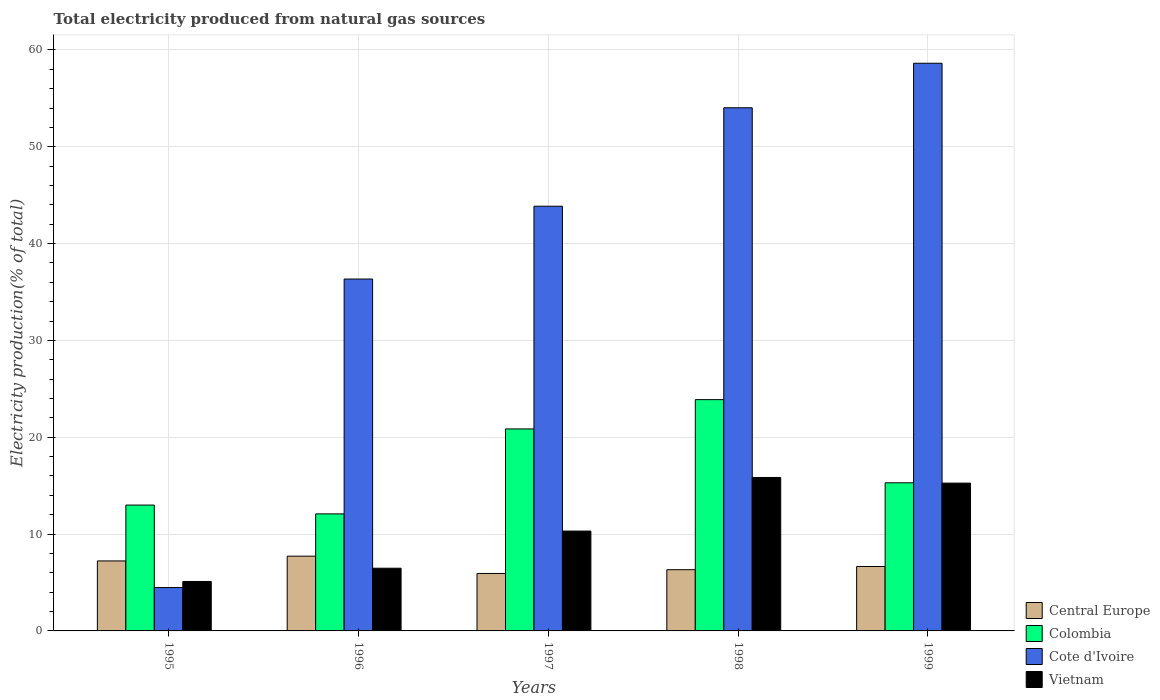How many groups of bars are there?
Offer a terse response. 5. How many bars are there on the 5th tick from the left?
Keep it short and to the point. 4. In how many cases, is the number of bars for a given year not equal to the number of legend labels?
Provide a succinct answer. 0. What is the total electricity produced in Colombia in 1998?
Keep it short and to the point. 23.89. Across all years, what is the maximum total electricity produced in Vietnam?
Offer a terse response. 15.85. Across all years, what is the minimum total electricity produced in Central Europe?
Offer a terse response. 5.93. In which year was the total electricity produced in Colombia maximum?
Keep it short and to the point. 1998. In which year was the total electricity produced in Vietnam minimum?
Provide a short and direct response. 1995. What is the total total electricity produced in Colombia in the graph?
Offer a terse response. 85.13. What is the difference between the total electricity produced in Cote d'Ivoire in 1996 and that in 1998?
Your answer should be compact. -17.69. What is the difference between the total electricity produced in Colombia in 1998 and the total electricity produced in Vietnam in 1995?
Your response must be concise. 18.78. What is the average total electricity produced in Vietnam per year?
Give a very brief answer. 10.6. In the year 1999, what is the difference between the total electricity produced in Colombia and total electricity produced in Cote d'Ivoire?
Offer a terse response. -43.33. What is the ratio of the total electricity produced in Central Europe in 1995 to that in 1999?
Provide a succinct answer. 1.09. Is the total electricity produced in Vietnam in 1996 less than that in 1999?
Keep it short and to the point. Yes. What is the difference between the highest and the second highest total electricity produced in Cote d'Ivoire?
Your answer should be very brief. 4.6. What is the difference between the highest and the lowest total electricity produced in Cote d'Ivoire?
Your answer should be very brief. 54.15. In how many years, is the total electricity produced in Colombia greater than the average total electricity produced in Colombia taken over all years?
Your response must be concise. 2. Is the sum of the total electricity produced in Vietnam in 1995 and 1998 greater than the maximum total electricity produced in Cote d'Ivoire across all years?
Keep it short and to the point. No. What does the 4th bar from the right in 1995 represents?
Provide a short and direct response. Central Europe. Is it the case that in every year, the sum of the total electricity produced in Cote d'Ivoire and total electricity produced in Colombia is greater than the total electricity produced in Vietnam?
Offer a very short reply. Yes. How many bars are there?
Offer a terse response. 20. What is the difference between two consecutive major ticks on the Y-axis?
Make the answer very short. 10. Are the values on the major ticks of Y-axis written in scientific E-notation?
Your answer should be very brief. No. Does the graph contain any zero values?
Make the answer very short. No. Does the graph contain grids?
Your response must be concise. Yes. Where does the legend appear in the graph?
Offer a terse response. Bottom right. How are the legend labels stacked?
Keep it short and to the point. Vertical. What is the title of the graph?
Ensure brevity in your answer.  Total electricity produced from natural gas sources. What is the label or title of the X-axis?
Make the answer very short. Years. What is the label or title of the Y-axis?
Make the answer very short. Electricity production(% of total). What is the Electricity production(% of total) in Central Europe in 1995?
Your answer should be compact. 7.23. What is the Electricity production(% of total) of Colombia in 1995?
Keep it short and to the point. 13. What is the Electricity production(% of total) of Cote d'Ivoire in 1995?
Offer a terse response. 4.48. What is the Electricity production(% of total) in Vietnam in 1995?
Offer a terse response. 5.11. What is the Electricity production(% of total) in Central Europe in 1996?
Provide a succinct answer. 7.72. What is the Electricity production(% of total) of Colombia in 1996?
Ensure brevity in your answer.  12.09. What is the Electricity production(% of total) in Cote d'Ivoire in 1996?
Provide a short and direct response. 36.34. What is the Electricity production(% of total) in Vietnam in 1996?
Offer a terse response. 6.47. What is the Electricity production(% of total) in Central Europe in 1997?
Offer a terse response. 5.93. What is the Electricity production(% of total) in Colombia in 1997?
Offer a terse response. 20.86. What is the Electricity production(% of total) of Cote d'Ivoire in 1997?
Give a very brief answer. 43.86. What is the Electricity production(% of total) of Vietnam in 1997?
Your response must be concise. 10.31. What is the Electricity production(% of total) in Central Europe in 1998?
Offer a terse response. 6.32. What is the Electricity production(% of total) of Colombia in 1998?
Provide a succinct answer. 23.89. What is the Electricity production(% of total) in Cote d'Ivoire in 1998?
Offer a very short reply. 54.03. What is the Electricity production(% of total) in Vietnam in 1998?
Provide a short and direct response. 15.85. What is the Electricity production(% of total) in Central Europe in 1999?
Your answer should be very brief. 6.65. What is the Electricity production(% of total) in Colombia in 1999?
Provide a short and direct response. 15.3. What is the Electricity production(% of total) in Cote d'Ivoire in 1999?
Your answer should be compact. 58.63. What is the Electricity production(% of total) in Vietnam in 1999?
Make the answer very short. 15.26. Across all years, what is the maximum Electricity production(% of total) in Central Europe?
Your answer should be compact. 7.72. Across all years, what is the maximum Electricity production(% of total) of Colombia?
Your answer should be very brief. 23.89. Across all years, what is the maximum Electricity production(% of total) in Cote d'Ivoire?
Your answer should be very brief. 58.63. Across all years, what is the maximum Electricity production(% of total) of Vietnam?
Offer a very short reply. 15.85. Across all years, what is the minimum Electricity production(% of total) of Central Europe?
Provide a short and direct response. 5.93. Across all years, what is the minimum Electricity production(% of total) in Colombia?
Provide a short and direct response. 12.09. Across all years, what is the minimum Electricity production(% of total) in Cote d'Ivoire?
Give a very brief answer. 4.48. Across all years, what is the minimum Electricity production(% of total) of Vietnam?
Offer a very short reply. 5.11. What is the total Electricity production(% of total) in Central Europe in the graph?
Provide a short and direct response. 33.86. What is the total Electricity production(% of total) of Colombia in the graph?
Provide a succinct answer. 85.13. What is the total Electricity production(% of total) of Cote d'Ivoire in the graph?
Offer a terse response. 197.33. What is the total Electricity production(% of total) in Vietnam in the graph?
Give a very brief answer. 53. What is the difference between the Electricity production(% of total) in Central Europe in 1995 and that in 1996?
Give a very brief answer. -0.49. What is the difference between the Electricity production(% of total) in Colombia in 1995 and that in 1996?
Your answer should be very brief. 0.91. What is the difference between the Electricity production(% of total) in Cote d'Ivoire in 1995 and that in 1996?
Keep it short and to the point. -31.86. What is the difference between the Electricity production(% of total) in Vietnam in 1995 and that in 1996?
Offer a very short reply. -1.37. What is the difference between the Electricity production(% of total) of Central Europe in 1995 and that in 1997?
Your answer should be very brief. 1.29. What is the difference between the Electricity production(% of total) in Colombia in 1995 and that in 1997?
Provide a short and direct response. -7.86. What is the difference between the Electricity production(% of total) in Cote d'Ivoire in 1995 and that in 1997?
Provide a short and direct response. -39.38. What is the difference between the Electricity production(% of total) in Vietnam in 1995 and that in 1997?
Make the answer very short. -5.21. What is the difference between the Electricity production(% of total) of Central Europe in 1995 and that in 1998?
Your answer should be very brief. 0.91. What is the difference between the Electricity production(% of total) in Colombia in 1995 and that in 1998?
Keep it short and to the point. -10.89. What is the difference between the Electricity production(% of total) in Cote d'Ivoire in 1995 and that in 1998?
Offer a terse response. -49.55. What is the difference between the Electricity production(% of total) of Vietnam in 1995 and that in 1998?
Keep it short and to the point. -10.74. What is the difference between the Electricity production(% of total) in Central Europe in 1995 and that in 1999?
Ensure brevity in your answer.  0.58. What is the difference between the Electricity production(% of total) of Colombia in 1995 and that in 1999?
Make the answer very short. -2.3. What is the difference between the Electricity production(% of total) of Cote d'Ivoire in 1995 and that in 1999?
Your answer should be very brief. -54.15. What is the difference between the Electricity production(% of total) of Vietnam in 1995 and that in 1999?
Your response must be concise. -10.16. What is the difference between the Electricity production(% of total) of Central Europe in 1996 and that in 1997?
Keep it short and to the point. 1.79. What is the difference between the Electricity production(% of total) in Colombia in 1996 and that in 1997?
Ensure brevity in your answer.  -8.77. What is the difference between the Electricity production(% of total) in Cote d'Ivoire in 1996 and that in 1997?
Provide a short and direct response. -7.52. What is the difference between the Electricity production(% of total) of Vietnam in 1996 and that in 1997?
Your answer should be very brief. -3.84. What is the difference between the Electricity production(% of total) in Central Europe in 1996 and that in 1998?
Provide a succinct answer. 1.4. What is the difference between the Electricity production(% of total) in Colombia in 1996 and that in 1998?
Your answer should be very brief. -11.8. What is the difference between the Electricity production(% of total) of Cote d'Ivoire in 1996 and that in 1998?
Offer a very short reply. -17.69. What is the difference between the Electricity production(% of total) of Vietnam in 1996 and that in 1998?
Provide a short and direct response. -9.37. What is the difference between the Electricity production(% of total) in Central Europe in 1996 and that in 1999?
Offer a very short reply. 1.07. What is the difference between the Electricity production(% of total) of Colombia in 1996 and that in 1999?
Your response must be concise. -3.21. What is the difference between the Electricity production(% of total) in Cote d'Ivoire in 1996 and that in 1999?
Your answer should be compact. -22.28. What is the difference between the Electricity production(% of total) in Vietnam in 1996 and that in 1999?
Your response must be concise. -8.79. What is the difference between the Electricity production(% of total) in Central Europe in 1997 and that in 1998?
Offer a very short reply. -0.39. What is the difference between the Electricity production(% of total) in Colombia in 1997 and that in 1998?
Your answer should be very brief. -3.02. What is the difference between the Electricity production(% of total) in Cote d'Ivoire in 1997 and that in 1998?
Offer a terse response. -10.17. What is the difference between the Electricity production(% of total) in Vietnam in 1997 and that in 1998?
Offer a very short reply. -5.53. What is the difference between the Electricity production(% of total) in Central Europe in 1997 and that in 1999?
Your response must be concise. -0.72. What is the difference between the Electricity production(% of total) in Colombia in 1997 and that in 1999?
Provide a short and direct response. 5.56. What is the difference between the Electricity production(% of total) in Cote d'Ivoire in 1997 and that in 1999?
Provide a short and direct response. -14.77. What is the difference between the Electricity production(% of total) of Vietnam in 1997 and that in 1999?
Give a very brief answer. -4.95. What is the difference between the Electricity production(% of total) in Central Europe in 1998 and that in 1999?
Your response must be concise. -0.33. What is the difference between the Electricity production(% of total) of Colombia in 1998 and that in 1999?
Keep it short and to the point. 8.59. What is the difference between the Electricity production(% of total) of Cote d'Ivoire in 1998 and that in 1999?
Offer a terse response. -4.6. What is the difference between the Electricity production(% of total) of Vietnam in 1998 and that in 1999?
Ensure brevity in your answer.  0.58. What is the difference between the Electricity production(% of total) of Central Europe in 1995 and the Electricity production(% of total) of Colombia in 1996?
Give a very brief answer. -4.86. What is the difference between the Electricity production(% of total) of Central Europe in 1995 and the Electricity production(% of total) of Cote d'Ivoire in 1996?
Provide a succinct answer. -29.11. What is the difference between the Electricity production(% of total) of Central Europe in 1995 and the Electricity production(% of total) of Vietnam in 1996?
Your response must be concise. 0.75. What is the difference between the Electricity production(% of total) in Colombia in 1995 and the Electricity production(% of total) in Cote d'Ivoire in 1996?
Provide a short and direct response. -23.34. What is the difference between the Electricity production(% of total) in Colombia in 1995 and the Electricity production(% of total) in Vietnam in 1996?
Provide a short and direct response. 6.52. What is the difference between the Electricity production(% of total) in Cote d'Ivoire in 1995 and the Electricity production(% of total) in Vietnam in 1996?
Make the answer very short. -2. What is the difference between the Electricity production(% of total) in Central Europe in 1995 and the Electricity production(% of total) in Colombia in 1997?
Provide a short and direct response. -13.63. What is the difference between the Electricity production(% of total) in Central Europe in 1995 and the Electricity production(% of total) in Cote d'Ivoire in 1997?
Offer a very short reply. -36.63. What is the difference between the Electricity production(% of total) of Central Europe in 1995 and the Electricity production(% of total) of Vietnam in 1997?
Keep it short and to the point. -3.08. What is the difference between the Electricity production(% of total) of Colombia in 1995 and the Electricity production(% of total) of Cote d'Ivoire in 1997?
Provide a short and direct response. -30.86. What is the difference between the Electricity production(% of total) of Colombia in 1995 and the Electricity production(% of total) of Vietnam in 1997?
Your answer should be very brief. 2.68. What is the difference between the Electricity production(% of total) of Cote d'Ivoire in 1995 and the Electricity production(% of total) of Vietnam in 1997?
Keep it short and to the point. -5.83. What is the difference between the Electricity production(% of total) of Central Europe in 1995 and the Electricity production(% of total) of Colombia in 1998?
Give a very brief answer. -16.66. What is the difference between the Electricity production(% of total) of Central Europe in 1995 and the Electricity production(% of total) of Cote d'Ivoire in 1998?
Offer a terse response. -46.8. What is the difference between the Electricity production(% of total) of Central Europe in 1995 and the Electricity production(% of total) of Vietnam in 1998?
Give a very brief answer. -8.62. What is the difference between the Electricity production(% of total) of Colombia in 1995 and the Electricity production(% of total) of Cote d'Ivoire in 1998?
Your answer should be very brief. -41.03. What is the difference between the Electricity production(% of total) in Colombia in 1995 and the Electricity production(% of total) in Vietnam in 1998?
Offer a very short reply. -2.85. What is the difference between the Electricity production(% of total) in Cote d'Ivoire in 1995 and the Electricity production(% of total) in Vietnam in 1998?
Offer a terse response. -11.37. What is the difference between the Electricity production(% of total) of Central Europe in 1995 and the Electricity production(% of total) of Colombia in 1999?
Keep it short and to the point. -8.07. What is the difference between the Electricity production(% of total) in Central Europe in 1995 and the Electricity production(% of total) in Cote d'Ivoire in 1999?
Your response must be concise. -51.4. What is the difference between the Electricity production(% of total) in Central Europe in 1995 and the Electricity production(% of total) in Vietnam in 1999?
Your answer should be very brief. -8.04. What is the difference between the Electricity production(% of total) of Colombia in 1995 and the Electricity production(% of total) of Cote d'Ivoire in 1999?
Give a very brief answer. -45.63. What is the difference between the Electricity production(% of total) of Colombia in 1995 and the Electricity production(% of total) of Vietnam in 1999?
Your answer should be compact. -2.27. What is the difference between the Electricity production(% of total) of Cote d'Ivoire in 1995 and the Electricity production(% of total) of Vietnam in 1999?
Provide a short and direct response. -10.78. What is the difference between the Electricity production(% of total) in Central Europe in 1996 and the Electricity production(% of total) in Colombia in 1997?
Your answer should be compact. -13.14. What is the difference between the Electricity production(% of total) of Central Europe in 1996 and the Electricity production(% of total) of Cote d'Ivoire in 1997?
Give a very brief answer. -36.14. What is the difference between the Electricity production(% of total) in Central Europe in 1996 and the Electricity production(% of total) in Vietnam in 1997?
Make the answer very short. -2.59. What is the difference between the Electricity production(% of total) in Colombia in 1996 and the Electricity production(% of total) in Cote d'Ivoire in 1997?
Your answer should be very brief. -31.77. What is the difference between the Electricity production(% of total) in Colombia in 1996 and the Electricity production(% of total) in Vietnam in 1997?
Give a very brief answer. 1.77. What is the difference between the Electricity production(% of total) in Cote d'Ivoire in 1996 and the Electricity production(% of total) in Vietnam in 1997?
Your response must be concise. 26.03. What is the difference between the Electricity production(% of total) of Central Europe in 1996 and the Electricity production(% of total) of Colombia in 1998?
Keep it short and to the point. -16.16. What is the difference between the Electricity production(% of total) of Central Europe in 1996 and the Electricity production(% of total) of Cote d'Ivoire in 1998?
Your answer should be compact. -46.31. What is the difference between the Electricity production(% of total) of Central Europe in 1996 and the Electricity production(% of total) of Vietnam in 1998?
Ensure brevity in your answer.  -8.13. What is the difference between the Electricity production(% of total) in Colombia in 1996 and the Electricity production(% of total) in Cote d'Ivoire in 1998?
Provide a succinct answer. -41.94. What is the difference between the Electricity production(% of total) of Colombia in 1996 and the Electricity production(% of total) of Vietnam in 1998?
Offer a very short reply. -3.76. What is the difference between the Electricity production(% of total) in Cote d'Ivoire in 1996 and the Electricity production(% of total) in Vietnam in 1998?
Your response must be concise. 20.49. What is the difference between the Electricity production(% of total) of Central Europe in 1996 and the Electricity production(% of total) of Colombia in 1999?
Provide a succinct answer. -7.58. What is the difference between the Electricity production(% of total) in Central Europe in 1996 and the Electricity production(% of total) in Cote d'Ivoire in 1999?
Provide a short and direct response. -50.9. What is the difference between the Electricity production(% of total) in Central Europe in 1996 and the Electricity production(% of total) in Vietnam in 1999?
Provide a succinct answer. -7.54. What is the difference between the Electricity production(% of total) of Colombia in 1996 and the Electricity production(% of total) of Cote d'Ivoire in 1999?
Your answer should be very brief. -46.54. What is the difference between the Electricity production(% of total) of Colombia in 1996 and the Electricity production(% of total) of Vietnam in 1999?
Your answer should be compact. -3.18. What is the difference between the Electricity production(% of total) of Cote d'Ivoire in 1996 and the Electricity production(% of total) of Vietnam in 1999?
Your answer should be compact. 21.08. What is the difference between the Electricity production(% of total) in Central Europe in 1997 and the Electricity production(% of total) in Colombia in 1998?
Your response must be concise. -17.95. What is the difference between the Electricity production(% of total) of Central Europe in 1997 and the Electricity production(% of total) of Cote d'Ivoire in 1998?
Offer a very short reply. -48.09. What is the difference between the Electricity production(% of total) of Central Europe in 1997 and the Electricity production(% of total) of Vietnam in 1998?
Your answer should be compact. -9.91. What is the difference between the Electricity production(% of total) of Colombia in 1997 and the Electricity production(% of total) of Cote d'Ivoire in 1998?
Your response must be concise. -33.17. What is the difference between the Electricity production(% of total) in Colombia in 1997 and the Electricity production(% of total) in Vietnam in 1998?
Your response must be concise. 5.01. What is the difference between the Electricity production(% of total) of Cote d'Ivoire in 1997 and the Electricity production(% of total) of Vietnam in 1998?
Offer a very short reply. 28.01. What is the difference between the Electricity production(% of total) of Central Europe in 1997 and the Electricity production(% of total) of Colombia in 1999?
Offer a very short reply. -9.36. What is the difference between the Electricity production(% of total) in Central Europe in 1997 and the Electricity production(% of total) in Cote d'Ivoire in 1999?
Your answer should be compact. -52.69. What is the difference between the Electricity production(% of total) of Central Europe in 1997 and the Electricity production(% of total) of Vietnam in 1999?
Make the answer very short. -9.33. What is the difference between the Electricity production(% of total) of Colombia in 1997 and the Electricity production(% of total) of Cote d'Ivoire in 1999?
Keep it short and to the point. -37.76. What is the difference between the Electricity production(% of total) in Colombia in 1997 and the Electricity production(% of total) in Vietnam in 1999?
Offer a terse response. 5.6. What is the difference between the Electricity production(% of total) in Cote d'Ivoire in 1997 and the Electricity production(% of total) in Vietnam in 1999?
Provide a short and direct response. 28.6. What is the difference between the Electricity production(% of total) of Central Europe in 1998 and the Electricity production(% of total) of Colombia in 1999?
Your answer should be compact. -8.97. What is the difference between the Electricity production(% of total) in Central Europe in 1998 and the Electricity production(% of total) in Cote d'Ivoire in 1999?
Offer a very short reply. -52.3. What is the difference between the Electricity production(% of total) in Central Europe in 1998 and the Electricity production(% of total) in Vietnam in 1999?
Offer a terse response. -8.94. What is the difference between the Electricity production(% of total) in Colombia in 1998 and the Electricity production(% of total) in Cote d'Ivoire in 1999?
Ensure brevity in your answer.  -34.74. What is the difference between the Electricity production(% of total) of Colombia in 1998 and the Electricity production(% of total) of Vietnam in 1999?
Provide a succinct answer. 8.62. What is the difference between the Electricity production(% of total) of Cote d'Ivoire in 1998 and the Electricity production(% of total) of Vietnam in 1999?
Offer a very short reply. 38.76. What is the average Electricity production(% of total) in Central Europe per year?
Give a very brief answer. 6.77. What is the average Electricity production(% of total) in Colombia per year?
Your response must be concise. 17.03. What is the average Electricity production(% of total) of Cote d'Ivoire per year?
Give a very brief answer. 39.47. What is the average Electricity production(% of total) in Vietnam per year?
Provide a short and direct response. 10.6. In the year 1995, what is the difference between the Electricity production(% of total) of Central Europe and Electricity production(% of total) of Colombia?
Give a very brief answer. -5.77. In the year 1995, what is the difference between the Electricity production(% of total) in Central Europe and Electricity production(% of total) in Cote d'Ivoire?
Your answer should be very brief. 2.75. In the year 1995, what is the difference between the Electricity production(% of total) in Central Europe and Electricity production(% of total) in Vietnam?
Your answer should be very brief. 2.12. In the year 1995, what is the difference between the Electricity production(% of total) of Colombia and Electricity production(% of total) of Cote d'Ivoire?
Provide a succinct answer. 8.52. In the year 1995, what is the difference between the Electricity production(% of total) of Colombia and Electricity production(% of total) of Vietnam?
Your answer should be compact. 7.89. In the year 1995, what is the difference between the Electricity production(% of total) of Cote d'Ivoire and Electricity production(% of total) of Vietnam?
Ensure brevity in your answer.  -0.63. In the year 1996, what is the difference between the Electricity production(% of total) of Central Europe and Electricity production(% of total) of Colombia?
Your answer should be compact. -4.37. In the year 1996, what is the difference between the Electricity production(% of total) of Central Europe and Electricity production(% of total) of Cote d'Ivoire?
Keep it short and to the point. -28.62. In the year 1996, what is the difference between the Electricity production(% of total) of Central Europe and Electricity production(% of total) of Vietnam?
Give a very brief answer. 1.25. In the year 1996, what is the difference between the Electricity production(% of total) in Colombia and Electricity production(% of total) in Cote d'Ivoire?
Offer a very short reply. -24.25. In the year 1996, what is the difference between the Electricity production(% of total) in Colombia and Electricity production(% of total) in Vietnam?
Your response must be concise. 5.61. In the year 1996, what is the difference between the Electricity production(% of total) of Cote d'Ivoire and Electricity production(% of total) of Vietnam?
Your answer should be very brief. 29.87. In the year 1997, what is the difference between the Electricity production(% of total) of Central Europe and Electricity production(% of total) of Colombia?
Provide a short and direct response. -14.93. In the year 1997, what is the difference between the Electricity production(% of total) of Central Europe and Electricity production(% of total) of Cote d'Ivoire?
Make the answer very short. -37.93. In the year 1997, what is the difference between the Electricity production(% of total) of Central Europe and Electricity production(% of total) of Vietnam?
Your response must be concise. -4.38. In the year 1997, what is the difference between the Electricity production(% of total) in Colombia and Electricity production(% of total) in Cote d'Ivoire?
Your answer should be compact. -23. In the year 1997, what is the difference between the Electricity production(% of total) in Colombia and Electricity production(% of total) in Vietnam?
Make the answer very short. 10.55. In the year 1997, what is the difference between the Electricity production(% of total) in Cote d'Ivoire and Electricity production(% of total) in Vietnam?
Offer a very short reply. 33.55. In the year 1998, what is the difference between the Electricity production(% of total) of Central Europe and Electricity production(% of total) of Colombia?
Your answer should be compact. -17.56. In the year 1998, what is the difference between the Electricity production(% of total) of Central Europe and Electricity production(% of total) of Cote d'Ivoire?
Make the answer very short. -47.7. In the year 1998, what is the difference between the Electricity production(% of total) of Central Europe and Electricity production(% of total) of Vietnam?
Make the answer very short. -9.52. In the year 1998, what is the difference between the Electricity production(% of total) of Colombia and Electricity production(% of total) of Cote d'Ivoire?
Your answer should be very brief. -30.14. In the year 1998, what is the difference between the Electricity production(% of total) in Colombia and Electricity production(% of total) in Vietnam?
Provide a succinct answer. 8.04. In the year 1998, what is the difference between the Electricity production(% of total) of Cote d'Ivoire and Electricity production(% of total) of Vietnam?
Keep it short and to the point. 38.18. In the year 1999, what is the difference between the Electricity production(% of total) of Central Europe and Electricity production(% of total) of Colombia?
Your response must be concise. -8.65. In the year 1999, what is the difference between the Electricity production(% of total) in Central Europe and Electricity production(% of total) in Cote d'Ivoire?
Your response must be concise. -51.97. In the year 1999, what is the difference between the Electricity production(% of total) of Central Europe and Electricity production(% of total) of Vietnam?
Your answer should be compact. -8.61. In the year 1999, what is the difference between the Electricity production(% of total) of Colombia and Electricity production(% of total) of Cote d'Ivoire?
Provide a short and direct response. -43.33. In the year 1999, what is the difference between the Electricity production(% of total) of Colombia and Electricity production(% of total) of Vietnam?
Offer a very short reply. 0.03. In the year 1999, what is the difference between the Electricity production(% of total) of Cote d'Ivoire and Electricity production(% of total) of Vietnam?
Your answer should be very brief. 43.36. What is the ratio of the Electricity production(% of total) of Central Europe in 1995 to that in 1996?
Provide a succinct answer. 0.94. What is the ratio of the Electricity production(% of total) of Colombia in 1995 to that in 1996?
Provide a succinct answer. 1.08. What is the ratio of the Electricity production(% of total) in Cote d'Ivoire in 1995 to that in 1996?
Provide a succinct answer. 0.12. What is the ratio of the Electricity production(% of total) of Vietnam in 1995 to that in 1996?
Provide a short and direct response. 0.79. What is the ratio of the Electricity production(% of total) of Central Europe in 1995 to that in 1997?
Offer a terse response. 1.22. What is the ratio of the Electricity production(% of total) in Colombia in 1995 to that in 1997?
Ensure brevity in your answer.  0.62. What is the ratio of the Electricity production(% of total) in Cote d'Ivoire in 1995 to that in 1997?
Your answer should be very brief. 0.1. What is the ratio of the Electricity production(% of total) in Vietnam in 1995 to that in 1997?
Your answer should be very brief. 0.5. What is the ratio of the Electricity production(% of total) in Central Europe in 1995 to that in 1998?
Make the answer very short. 1.14. What is the ratio of the Electricity production(% of total) in Colombia in 1995 to that in 1998?
Give a very brief answer. 0.54. What is the ratio of the Electricity production(% of total) in Cote d'Ivoire in 1995 to that in 1998?
Give a very brief answer. 0.08. What is the ratio of the Electricity production(% of total) in Vietnam in 1995 to that in 1998?
Make the answer very short. 0.32. What is the ratio of the Electricity production(% of total) of Central Europe in 1995 to that in 1999?
Ensure brevity in your answer.  1.09. What is the ratio of the Electricity production(% of total) in Colombia in 1995 to that in 1999?
Ensure brevity in your answer.  0.85. What is the ratio of the Electricity production(% of total) of Cote d'Ivoire in 1995 to that in 1999?
Provide a succinct answer. 0.08. What is the ratio of the Electricity production(% of total) in Vietnam in 1995 to that in 1999?
Keep it short and to the point. 0.33. What is the ratio of the Electricity production(% of total) in Central Europe in 1996 to that in 1997?
Give a very brief answer. 1.3. What is the ratio of the Electricity production(% of total) of Colombia in 1996 to that in 1997?
Provide a succinct answer. 0.58. What is the ratio of the Electricity production(% of total) in Cote d'Ivoire in 1996 to that in 1997?
Keep it short and to the point. 0.83. What is the ratio of the Electricity production(% of total) in Vietnam in 1996 to that in 1997?
Offer a terse response. 0.63. What is the ratio of the Electricity production(% of total) in Central Europe in 1996 to that in 1998?
Give a very brief answer. 1.22. What is the ratio of the Electricity production(% of total) in Colombia in 1996 to that in 1998?
Keep it short and to the point. 0.51. What is the ratio of the Electricity production(% of total) in Cote d'Ivoire in 1996 to that in 1998?
Provide a short and direct response. 0.67. What is the ratio of the Electricity production(% of total) of Vietnam in 1996 to that in 1998?
Ensure brevity in your answer.  0.41. What is the ratio of the Electricity production(% of total) of Central Europe in 1996 to that in 1999?
Offer a very short reply. 1.16. What is the ratio of the Electricity production(% of total) of Colombia in 1996 to that in 1999?
Make the answer very short. 0.79. What is the ratio of the Electricity production(% of total) in Cote d'Ivoire in 1996 to that in 1999?
Make the answer very short. 0.62. What is the ratio of the Electricity production(% of total) in Vietnam in 1996 to that in 1999?
Give a very brief answer. 0.42. What is the ratio of the Electricity production(% of total) of Central Europe in 1997 to that in 1998?
Give a very brief answer. 0.94. What is the ratio of the Electricity production(% of total) in Colombia in 1997 to that in 1998?
Give a very brief answer. 0.87. What is the ratio of the Electricity production(% of total) in Cote d'Ivoire in 1997 to that in 1998?
Your answer should be compact. 0.81. What is the ratio of the Electricity production(% of total) in Vietnam in 1997 to that in 1998?
Ensure brevity in your answer.  0.65. What is the ratio of the Electricity production(% of total) in Central Europe in 1997 to that in 1999?
Your response must be concise. 0.89. What is the ratio of the Electricity production(% of total) in Colombia in 1997 to that in 1999?
Your response must be concise. 1.36. What is the ratio of the Electricity production(% of total) in Cote d'Ivoire in 1997 to that in 1999?
Ensure brevity in your answer.  0.75. What is the ratio of the Electricity production(% of total) in Vietnam in 1997 to that in 1999?
Ensure brevity in your answer.  0.68. What is the ratio of the Electricity production(% of total) of Central Europe in 1998 to that in 1999?
Offer a terse response. 0.95. What is the ratio of the Electricity production(% of total) of Colombia in 1998 to that in 1999?
Keep it short and to the point. 1.56. What is the ratio of the Electricity production(% of total) of Cote d'Ivoire in 1998 to that in 1999?
Keep it short and to the point. 0.92. What is the ratio of the Electricity production(% of total) of Vietnam in 1998 to that in 1999?
Keep it short and to the point. 1.04. What is the difference between the highest and the second highest Electricity production(% of total) in Central Europe?
Provide a short and direct response. 0.49. What is the difference between the highest and the second highest Electricity production(% of total) of Colombia?
Keep it short and to the point. 3.02. What is the difference between the highest and the second highest Electricity production(% of total) of Cote d'Ivoire?
Offer a terse response. 4.6. What is the difference between the highest and the second highest Electricity production(% of total) of Vietnam?
Ensure brevity in your answer.  0.58. What is the difference between the highest and the lowest Electricity production(% of total) of Central Europe?
Offer a very short reply. 1.79. What is the difference between the highest and the lowest Electricity production(% of total) in Colombia?
Make the answer very short. 11.8. What is the difference between the highest and the lowest Electricity production(% of total) in Cote d'Ivoire?
Make the answer very short. 54.15. What is the difference between the highest and the lowest Electricity production(% of total) in Vietnam?
Offer a terse response. 10.74. 